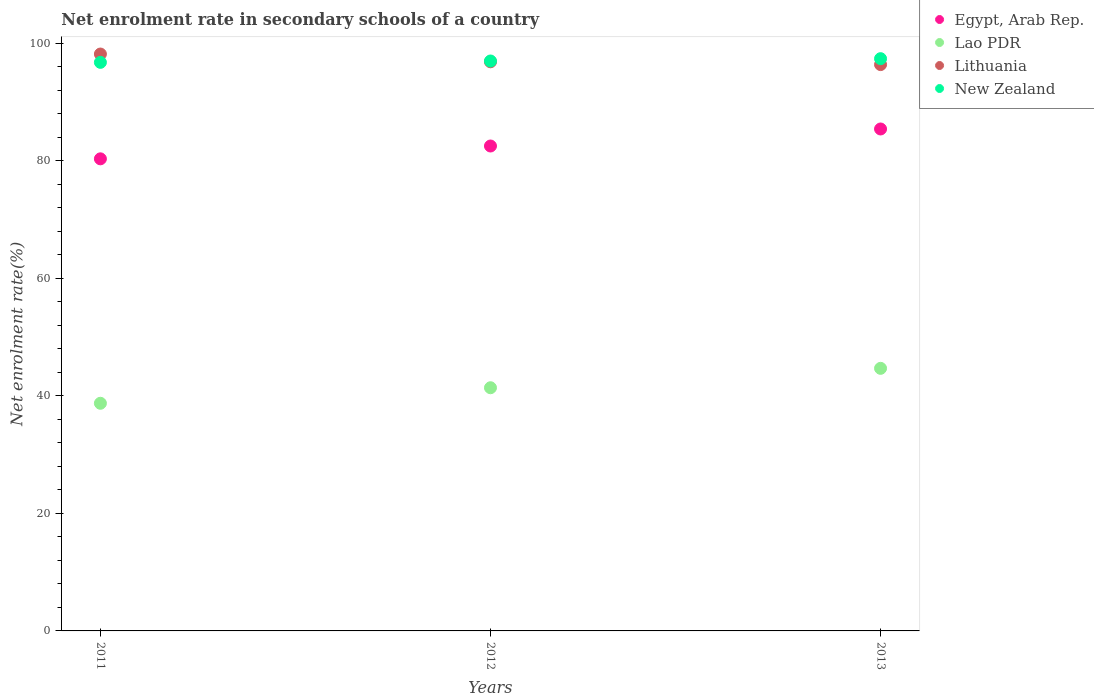How many different coloured dotlines are there?
Your answer should be compact. 4. Is the number of dotlines equal to the number of legend labels?
Offer a terse response. Yes. What is the net enrolment rate in secondary schools in Lithuania in 2011?
Offer a very short reply. 98.14. Across all years, what is the maximum net enrolment rate in secondary schools in Egypt, Arab Rep.?
Provide a succinct answer. 85.39. Across all years, what is the minimum net enrolment rate in secondary schools in New Zealand?
Your answer should be very brief. 96.73. What is the total net enrolment rate in secondary schools in Egypt, Arab Rep. in the graph?
Your answer should be very brief. 248.2. What is the difference between the net enrolment rate in secondary schools in Lithuania in 2011 and that in 2013?
Make the answer very short. 1.8. What is the difference between the net enrolment rate in secondary schools in Lao PDR in 2011 and the net enrolment rate in secondary schools in Egypt, Arab Rep. in 2012?
Provide a succinct answer. -43.77. What is the average net enrolment rate in secondary schools in New Zealand per year?
Provide a short and direct response. 97.01. In the year 2011, what is the difference between the net enrolment rate in secondary schools in New Zealand and net enrolment rate in secondary schools in Lithuania?
Your answer should be compact. -1.42. In how many years, is the net enrolment rate in secondary schools in Lao PDR greater than 24 %?
Give a very brief answer. 3. What is the ratio of the net enrolment rate in secondary schools in New Zealand in 2011 to that in 2012?
Make the answer very short. 1. Is the difference between the net enrolment rate in secondary schools in New Zealand in 2011 and 2012 greater than the difference between the net enrolment rate in secondary schools in Lithuania in 2011 and 2012?
Give a very brief answer. No. What is the difference between the highest and the second highest net enrolment rate in secondary schools in Lao PDR?
Your response must be concise. 3.3. What is the difference between the highest and the lowest net enrolment rate in secondary schools in Lithuania?
Offer a terse response. 1.8. In how many years, is the net enrolment rate in secondary schools in Lithuania greater than the average net enrolment rate in secondary schools in Lithuania taken over all years?
Offer a very short reply. 1. Is the sum of the net enrolment rate in secondary schools in Lao PDR in 2011 and 2012 greater than the maximum net enrolment rate in secondary schools in New Zealand across all years?
Keep it short and to the point. No. Is it the case that in every year, the sum of the net enrolment rate in secondary schools in Lao PDR and net enrolment rate in secondary schools in Lithuania  is greater than the sum of net enrolment rate in secondary schools in Egypt, Arab Rep. and net enrolment rate in secondary schools in New Zealand?
Your response must be concise. No. Does the net enrolment rate in secondary schools in Egypt, Arab Rep. monotonically increase over the years?
Offer a terse response. Yes. Is the net enrolment rate in secondary schools in Lithuania strictly greater than the net enrolment rate in secondary schools in Lao PDR over the years?
Give a very brief answer. Yes. Is the net enrolment rate in secondary schools in Egypt, Arab Rep. strictly less than the net enrolment rate in secondary schools in Lithuania over the years?
Keep it short and to the point. Yes. How many years are there in the graph?
Offer a very short reply. 3. What is the difference between two consecutive major ticks on the Y-axis?
Your answer should be compact. 20. Are the values on the major ticks of Y-axis written in scientific E-notation?
Your answer should be compact. No. Where does the legend appear in the graph?
Ensure brevity in your answer.  Top right. How many legend labels are there?
Offer a terse response. 4. How are the legend labels stacked?
Your response must be concise. Vertical. What is the title of the graph?
Your answer should be very brief. Net enrolment rate in secondary schools of a country. Does "Bhutan" appear as one of the legend labels in the graph?
Make the answer very short. No. What is the label or title of the Y-axis?
Offer a terse response. Net enrolment rate(%). What is the Net enrolment rate(%) of Egypt, Arab Rep. in 2011?
Provide a succinct answer. 80.32. What is the Net enrolment rate(%) of Lao PDR in 2011?
Make the answer very short. 38.73. What is the Net enrolment rate(%) of Lithuania in 2011?
Provide a short and direct response. 98.14. What is the Net enrolment rate(%) of New Zealand in 2011?
Your answer should be compact. 96.73. What is the Net enrolment rate(%) in Egypt, Arab Rep. in 2012?
Ensure brevity in your answer.  82.5. What is the Net enrolment rate(%) in Lao PDR in 2012?
Provide a short and direct response. 41.37. What is the Net enrolment rate(%) of Lithuania in 2012?
Provide a short and direct response. 96.82. What is the Net enrolment rate(%) of New Zealand in 2012?
Ensure brevity in your answer.  96.96. What is the Net enrolment rate(%) of Egypt, Arab Rep. in 2013?
Ensure brevity in your answer.  85.39. What is the Net enrolment rate(%) in Lao PDR in 2013?
Your answer should be very brief. 44.67. What is the Net enrolment rate(%) in Lithuania in 2013?
Offer a very short reply. 96.35. What is the Net enrolment rate(%) in New Zealand in 2013?
Your answer should be very brief. 97.35. Across all years, what is the maximum Net enrolment rate(%) of Egypt, Arab Rep.?
Your answer should be very brief. 85.39. Across all years, what is the maximum Net enrolment rate(%) in Lao PDR?
Make the answer very short. 44.67. Across all years, what is the maximum Net enrolment rate(%) in Lithuania?
Give a very brief answer. 98.14. Across all years, what is the maximum Net enrolment rate(%) of New Zealand?
Your response must be concise. 97.35. Across all years, what is the minimum Net enrolment rate(%) in Egypt, Arab Rep.?
Your answer should be very brief. 80.32. Across all years, what is the minimum Net enrolment rate(%) of Lao PDR?
Keep it short and to the point. 38.73. Across all years, what is the minimum Net enrolment rate(%) of Lithuania?
Ensure brevity in your answer.  96.35. Across all years, what is the minimum Net enrolment rate(%) of New Zealand?
Your response must be concise. 96.73. What is the total Net enrolment rate(%) of Egypt, Arab Rep. in the graph?
Make the answer very short. 248.2. What is the total Net enrolment rate(%) in Lao PDR in the graph?
Provide a short and direct response. 124.77. What is the total Net enrolment rate(%) of Lithuania in the graph?
Your answer should be very brief. 291.31. What is the total Net enrolment rate(%) of New Zealand in the graph?
Offer a very short reply. 291.04. What is the difference between the Net enrolment rate(%) in Egypt, Arab Rep. in 2011 and that in 2012?
Offer a very short reply. -2.18. What is the difference between the Net enrolment rate(%) in Lao PDR in 2011 and that in 2012?
Offer a terse response. -2.64. What is the difference between the Net enrolment rate(%) of Lithuania in 2011 and that in 2012?
Offer a terse response. 1.32. What is the difference between the Net enrolment rate(%) of New Zealand in 2011 and that in 2012?
Provide a short and direct response. -0.23. What is the difference between the Net enrolment rate(%) of Egypt, Arab Rep. in 2011 and that in 2013?
Your answer should be very brief. -5.08. What is the difference between the Net enrolment rate(%) in Lao PDR in 2011 and that in 2013?
Offer a terse response. -5.94. What is the difference between the Net enrolment rate(%) in Lithuania in 2011 and that in 2013?
Provide a short and direct response. 1.8. What is the difference between the Net enrolment rate(%) in New Zealand in 2011 and that in 2013?
Provide a short and direct response. -0.63. What is the difference between the Net enrolment rate(%) in Egypt, Arab Rep. in 2012 and that in 2013?
Provide a succinct answer. -2.9. What is the difference between the Net enrolment rate(%) of Lao PDR in 2012 and that in 2013?
Your answer should be compact. -3.3. What is the difference between the Net enrolment rate(%) of Lithuania in 2012 and that in 2013?
Your response must be concise. 0.48. What is the difference between the Net enrolment rate(%) in New Zealand in 2012 and that in 2013?
Offer a very short reply. -0.4. What is the difference between the Net enrolment rate(%) in Egypt, Arab Rep. in 2011 and the Net enrolment rate(%) in Lao PDR in 2012?
Offer a terse response. 38.94. What is the difference between the Net enrolment rate(%) of Egypt, Arab Rep. in 2011 and the Net enrolment rate(%) of Lithuania in 2012?
Give a very brief answer. -16.51. What is the difference between the Net enrolment rate(%) of Egypt, Arab Rep. in 2011 and the Net enrolment rate(%) of New Zealand in 2012?
Offer a very short reply. -16.64. What is the difference between the Net enrolment rate(%) in Lao PDR in 2011 and the Net enrolment rate(%) in Lithuania in 2012?
Provide a succinct answer. -58.09. What is the difference between the Net enrolment rate(%) of Lao PDR in 2011 and the Net enrolment rate(%) of New Zealand in 2012?
Offer a terse response. -58.23. What is the difference between the Net enrolment rate(%) in Lithuania in 2011 and the Net enrolment rate(%) in New Zealand in 2012?
Your response must be concise. 1.18. What is the difference between the Net enrolment rate(%) of Egypt, Arab Rep. in 2011 and the Net enrolment rate(%) of Lao PDR in 2013?
Offer a very short reply. 35.64. What is the difference between the Net enrolment rate(%) in Egypt, Arab Rep. in 2011 and the Net enrolment rate(%) in Lithuania in 2013?
Provide a short and direct response. -16.03. What is the difference between the Net enrolment rate(%) in Egypt, Arab Rep. in 2011 and the Net enrolment rate(%) in New Zealand in 2013?
Ensure brevity in your answer.  -17.04. What is the difference between the Net enrolment rate(%) of Lao PDR in 2011 and the Net enrolment rate(%) of Lithuania in 2013?
Keep it short and to the point. -57.62. What is the difference between the Net enrolment rate(%) of Lao PDR in 2011 and the Net enrolment rate(%) of New Zealand in 2013?
Make the answer very short. -58.63. What is the difference between the Net enrolment rate(%) in Lithuania in 2011 and the Net enrolment rate(%) in New Zealand in 2013?
Your response must be concise. 0.79. What is the difference between the Net enrolment rate(%) in Egypt, Arab Rep. in 2012 and the Net enrolment rate(%) in Lao PDR in 2013?
Your answer should be very brief. 37.82. What is the difference between the Net enrolment rate(%) of Egypt, Arab Rep. in 2012 and the Net enrolment rate(%) of Lithuania in 2013?
Keep it short and to the point. -13.85. What is the difference between the Net enrolment rate(%) in Egypt, Arab Rep. in 2012 and the Net enrolment rate(%) in New Zealand in 2013?
Offer a very short reply. -14.86. What is the difference between the Net enrolment rate(%) in Lao PDR in 2012 and the Net enrolment rate(%) in Lithuania in 2013?
Your response must be concise. -54.98. What is the difference between the Net enrolment rate(%) in Lao PDR in 2012 and the Net enrolment rate(%) in New Zealand in 2013?
Make the answer very short. -55.98. What is the difference between the Net enrolment rate(%) of Lithuania in 2012 and the Net enrolment rate(%) of New Zealand in 2013?
Your answer should be very brief. -0.53. What is the average Net enrolment rate(%) in Egypt, Arab Rep. per year?
Offer a very short reply. 82.73. What is the average Net enrolment rate(%) in Lao PDR per year?
Give a very brief answer. 41.59. What is the average Net enrolment rate(%) in Lithuania per year?
Offer a very short reply. 97.1. What is the average Net enrolment rate(%) in New Zealand per year?
Your response must be concise. 97.01. In the year 2011, what is the difference between the Net enrolment rate(%) of Egypt, Arab Rep. and Net enrolment rate(%) of Lao PDR?
Your answer should be very brief. 41.59. In the year 2011, what is the difference between the Net enrolment rate(%) of Egypt, Arab Rep. and Net enrolment rate(%) of Lithuania?
Offer a very short reply. -17.83. In the year 2011, what is the difference between the Net enrolment rate(%) of Egypt, Arab Rep. and Net enrolment rate(%) of New Zealand?
Make the answer very short. -16.41. In the year 2011, what is the difference between the Net enrolment rate(%) of Lao PDR and Net enrolment rate(%) of Lithuania?
Give a very brief answer. -59.41. In the year 2011, what is the difference between the Net enrolment rate(%) in Lao PDR and Net enrolment rate(%) in New Zealand?
Provide a short and direct response. -58. In the year 2011, what is the difference between the Net enrolment rate(%) in Lithuania and Net enrolment rate(%) in New Zealand?
Keep it short and to the point. 1.42. In the year 2012, what is the difference between the Net enrolment rate(%) in Egypt, Arab Rep. and Net enrolment rate(%) in Lao PDR?
Provide a short and direct response. 41.13. In the year 2012, what is the difference between the Net enrolment rate(%) in Egypt, Arab Rep. and Net enrolment rate(%) in Lithuania?
Your answer should be very brief. -14.33. In the year 2012, what is the difference between the Net enrolment rate(%) in Egypt, Arab Rep. and Net enrolment rate(%) in New Zealand?
Make the answer very short. -14.46. In the year 2012, what is the difference between the Net enrolment rate(%) of Lao PDR and Net enrolment rate(%) of Lithuania?
Ensure brevity in your answer.  -55.45. In the year 2012, what is the difference between the Net enrolment rate(%) of Lao PDR and Net enrolment rate(%) of New Zealand?
Make the answer very short. -55.59. In the year 2012, what is the difference between the Net enrolment rate(%) of Lithuania and Net enrolment rate(%) of New Zealand?
Keep it short and to the point. -0.14. In the year 2013, what is the difference between the Net enrolment rate(%) of Egypt, Arab Rep. and Net enrolment rate(%) of Lao PDR?
Your answer should be very brief. 40.72. In the year 2013, what is the difference between the Net enrolment rate(%) in Egypt, Arab Rep. and Net enrolment rate(%) in Lithuania?
Make the answer very short. -10.95. In the year 2013, what is the difference between the Net enrolment rate(%) of Egypt, Arab Rep. and Net enrolment rate(%) of New Zealand?
Your answer should be compact. -11.96. In the year 2013, what is the difference between the Net enrolment rate(%) in Lao PDR and Net enrolment rate(%) in Lithuania?
Keep it short and to the point. -51.67. In the year 2013, what is the difference between the Net enrolment rate(%) of Lao PDR and Net enrolment rate(%) of New Zealand?
Make the answer very short. -52.68. In the year 2013, what is the difference between the Net enrolment rate(%) in Lithuania and Net enrolment rate(%) in New Zealand?
Provide a short and direct response. -1.01. What is the ratio of the Net enrolment rate(%) of Egypt, Arab Rep. in 2011 to that in 2012?
Your answer should be compact. 0.97. What is the ratio of the Net enrolment rate(%) in Lao PDR in 2011 to that in 2012?
Make the answer very short. 0.94. What is the ratio of the Net enrolment rate(%) of Lithuania in 2011 to that in 2012?
Keep it short and to the point. 1.01. What is the ratio of the Net enrolment rate(%) of New Zealand in 2011 to that in 2012?
Provide a short and direct response. 1. What is the ratio of the Net enrolment rate(%) of Egypt, Arab Rep. in 2011 to that in 2013?
Make the answer very short. 0.94. What is the ratio of the Net enrolment rate(%) in Lao PDR in 2011 to that in 2013?
Provide a succinct answer. 0.87. What is the ratio of the Net enrolment rate(%) of Lithuania in 2011 to that in 2013?
Provide a succinct answer. 1.02. What is the ratio of the Net enrolment rate(%) in Egypt, Arab Rep. in 2012 to that in 2013?
Ensure brevity in your answer.  0.97. What is the ratio of the Net enrolment rate(%) of Lao PDR in 2012 to that in 2013?
Provide a short and direct response. 0.93. What is the ratio of the Net enrolment rate(%) in Lithuania in 2012 to that in 2013?
Make the answer very short. 1. What is the difference between the highest and the second highest Net enrolment rate(%) in Egypt, Arab Rep.?
Keep it short and to the point. 2.9. What is the difference between the highest and the second highest Net enrolment rate(%) in Lao PDR?
Make the answer very short. 3.3. What is the difference between the highest and the second highest Net enrolment rate(%) of Lithuania?
Give a very brief answer. 1.32. What is the difference between the highest and the second highest Net enrolment rate(%) in New Zealand?
Offer a terse response. 0.4. What is the difference between the highest and the lowest Net enrolment rate(%) in Egypt, Arab Rep.?
Keep it short and to the point. 5.08. What is the difference between the highest and the lowest Net enrolment rate(%) in Lao PDR?
Ensure brevity in your answer.  5.94. What is the difference between the highest and the lowest Net enrolment rate(%) in Lithuania?
Make the answer very short. 1.8. What is the difference between the highest and the lowest Net enrolment rate(%) of New Zealand?
Your answer should be compact. 0.63. 